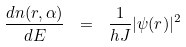Convert formula to latex. <formula><loc_0><loc_0><loc_500><loc_500>\frac { d n ( { r } , \alpha ) } { d E } \ = \ \frac { 1 } { h J } | \psi ( { r } ) | ^ { 2 }</formula> 